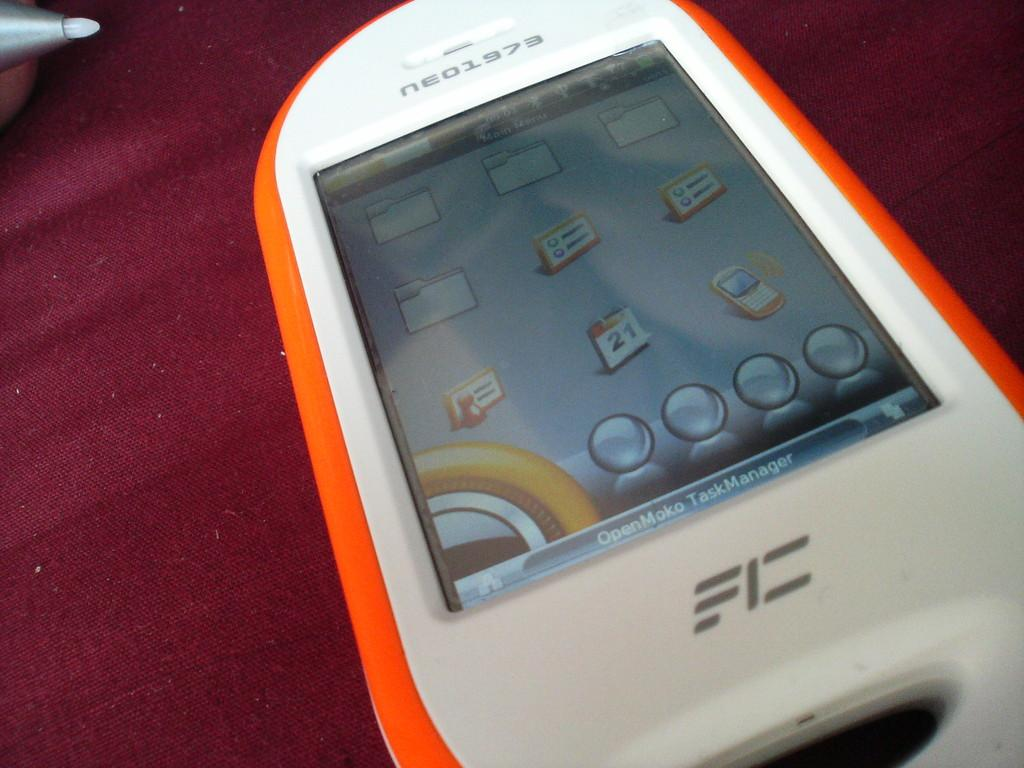Provide a one-sentence caption for the provided image. orange and white cell phone that has neo1973 at top of it on a wooden surface. 